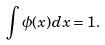Convert formula to latex. <formula><loc_0><loc_0><loc_500><loc_500>\int \phi ( x ) d x = 1 .</formula> 